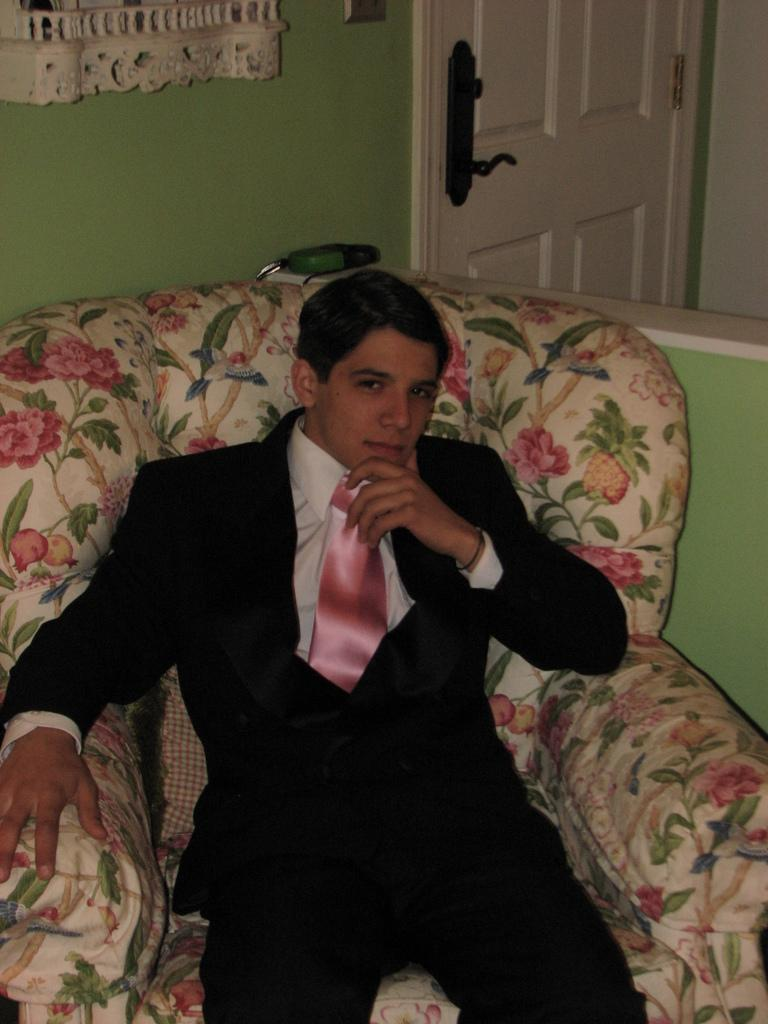Who is present in the image? There is a man in the image. What is the man doing in the image? The man is sitting on a couch. What is the man wearing in the image? The man is wearing a coat and tie. What can be seen in the background of the image? There is a wall, a door, a door handle, and an object in the background of the image. What word is the man saying in the image? There is no indication in the image that the man is saying any words, so it cannot be determined from the picture. 